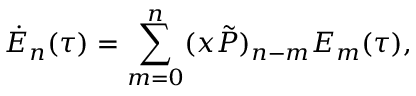Convert formula to latex. <formula><loc_0><loc_0><loc_500><loc_500>\dot { E } _ { n } ( \tau ) = \sum _ { m = 0 } ^ { n } ( x \tilde { P } ) _ { n - m } E _ { m } ( \tau ) ,</formula> 